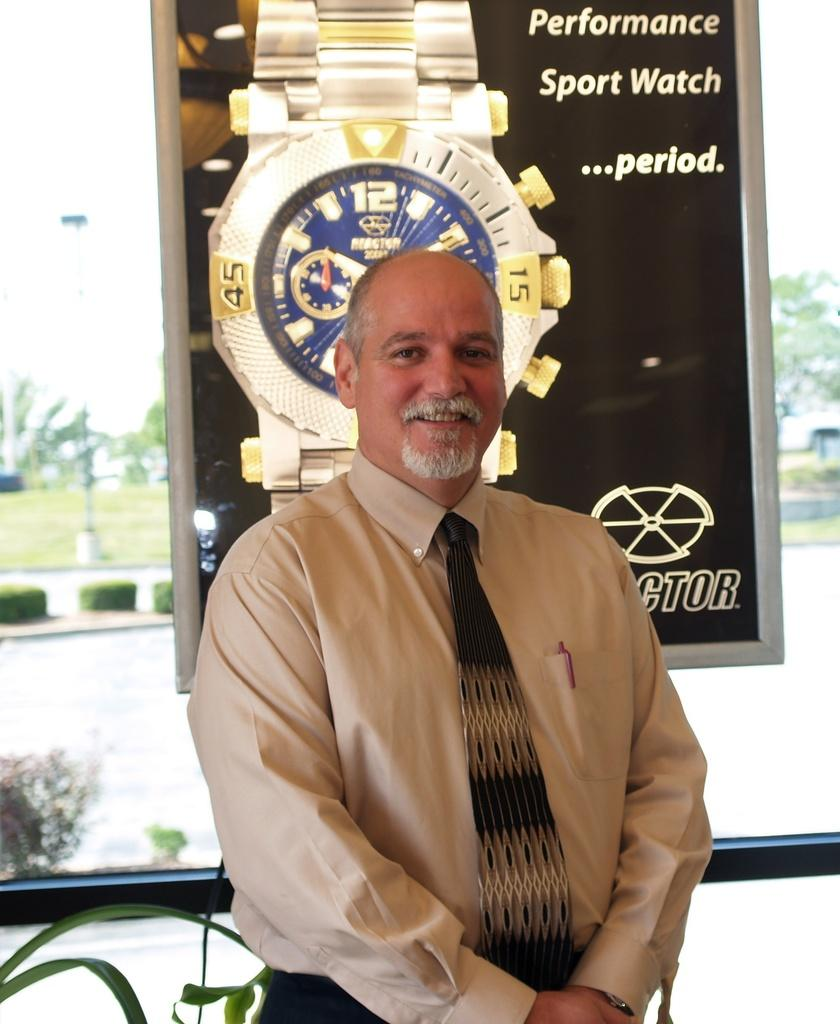<image>
Offer a succinct explanation of the picture presented. A man stands in front of a poster for a sport watch. 